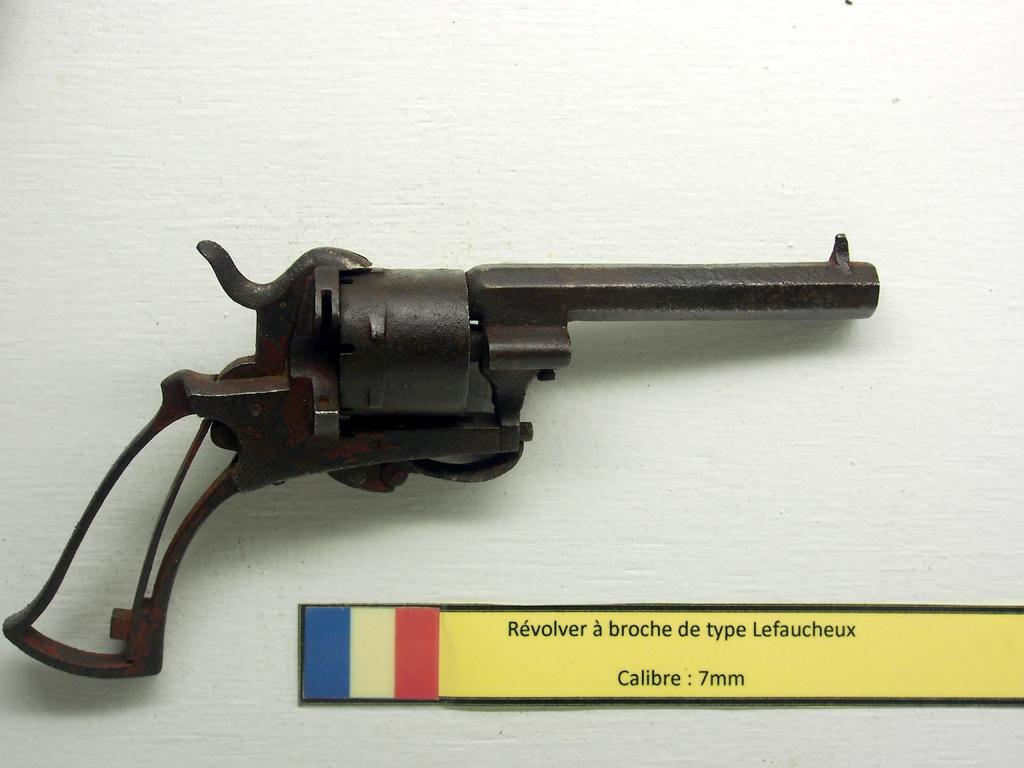What is the main object in the image? There is a gun in the image. Can you describe any other objects or features in the image? There is a board on an object in the image. How many babies are present in the image? There are no babies present in the image. What decision is being made in the image? There is no indication of a decision being made in the image. 